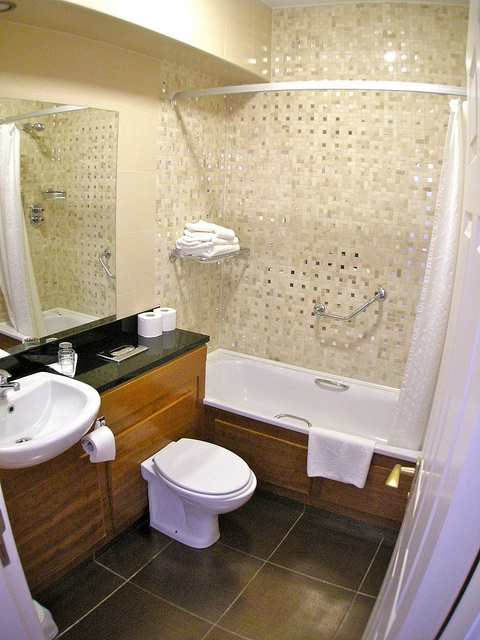Describe the objects in this image and their specific colors. I can see toilet in gray and lightgray tones, sink in gray, lightgray, and darkgray tones, and cup in gray, white, darkgray, and lightgray tones in this image. 